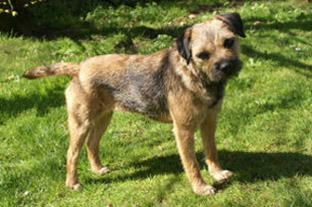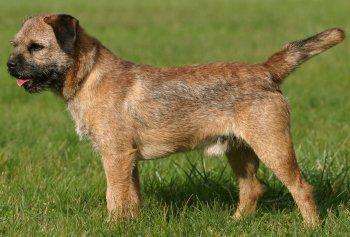The first image is the image on the left, the second image is the image on the right. Considering the images on both sides, is "The dogs in the right and left images have the same pose and face the same direction." valid? Answer yes or no. No. The first image is the image on the left, the second image is the image on the right. Analyze the images presented: Is the assertion "Both dogs are standing in profile and facing the same direction." valid? Answer yes or no. No. 